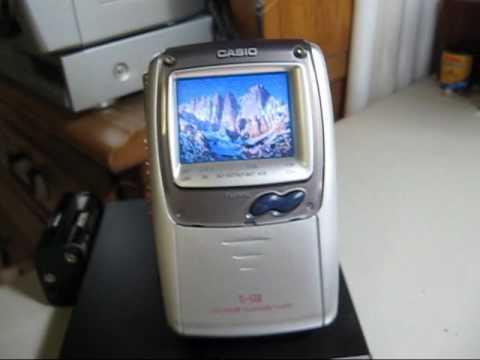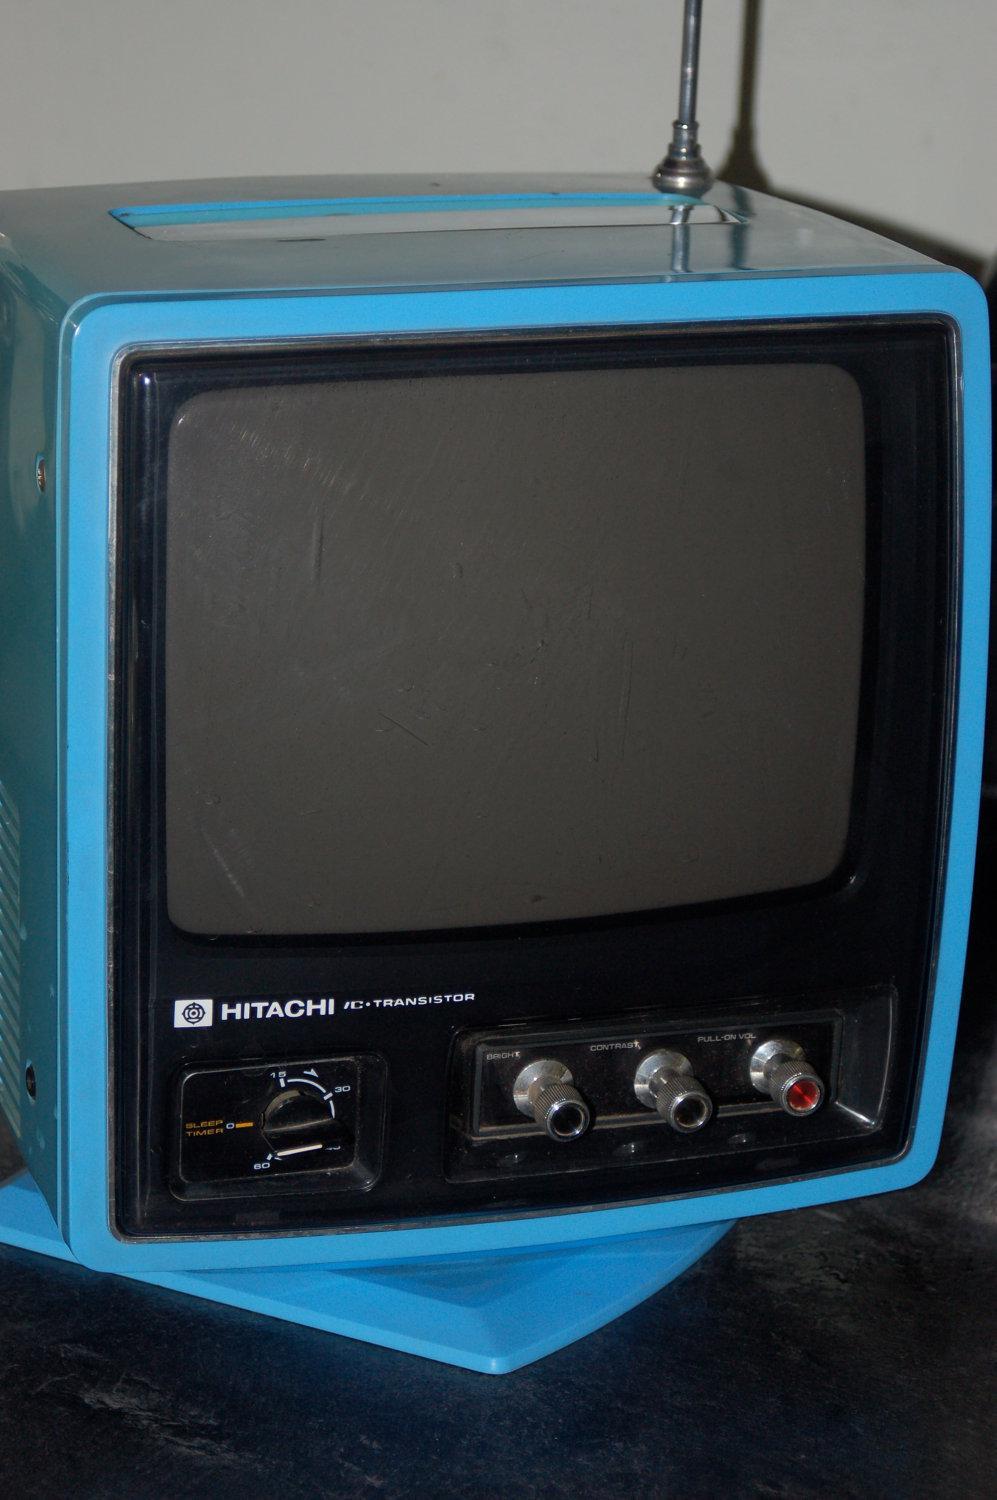The first image is the image on the left, the second image is the image on the right. Examine the images to the left and right. Is the description "One of the images shows a video game controller near a television." accurate? Answer yes or no. No. The first image is the image on the left, the second image is the image on the right. Considering the images on both sides, is "One TV has a handle projecting from the top, and the other TV has an orange case and sits on a table by a game controller." valid? Answer yes or no. No. 